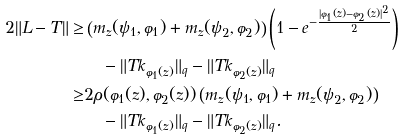Convert formula to latex. <formula><loc_0><loc_0><loc_500><loc_500>2 \| L - T \| \geq & \left ( m _ { z } ( \psi _ { 1 } , \varphi _ { 1 } ) + m _ { z } ( \psi _ { 2 } , \varphi _ { 2 } ) \right ) \left ( 1 - e ^ { - \frac { | \varphi _ { 1 } ( z ) - \varphi _ { 2 } ( z ) | ^ { 2 } } { 2 } } \right ) \\ & \quad - \| T k _ { \varphi _ { 1 } ( z ) } \| _ { q } - \| T k _ { \varphi _ { 2 } ( z ) } \| _ { q } \\ \geq & 2 \rho ( \varphi _ { 1 } ( z ) , \varphi _ { 2 } ( z ) ) \left ( m _ { z } ( \psi _ { 1 } , \varphi _ { 1 } ) + m _ { z } ( \psi _ { 2 } , \varphi _ { 2 } ) \right ) \\ & \quad - \| T k _ { \varphi _ { 1 } ( z ) } \| _ { q } - \| T k _ { \varphi _ { 2 } ( z ) } \| _ { q } .</formula> 